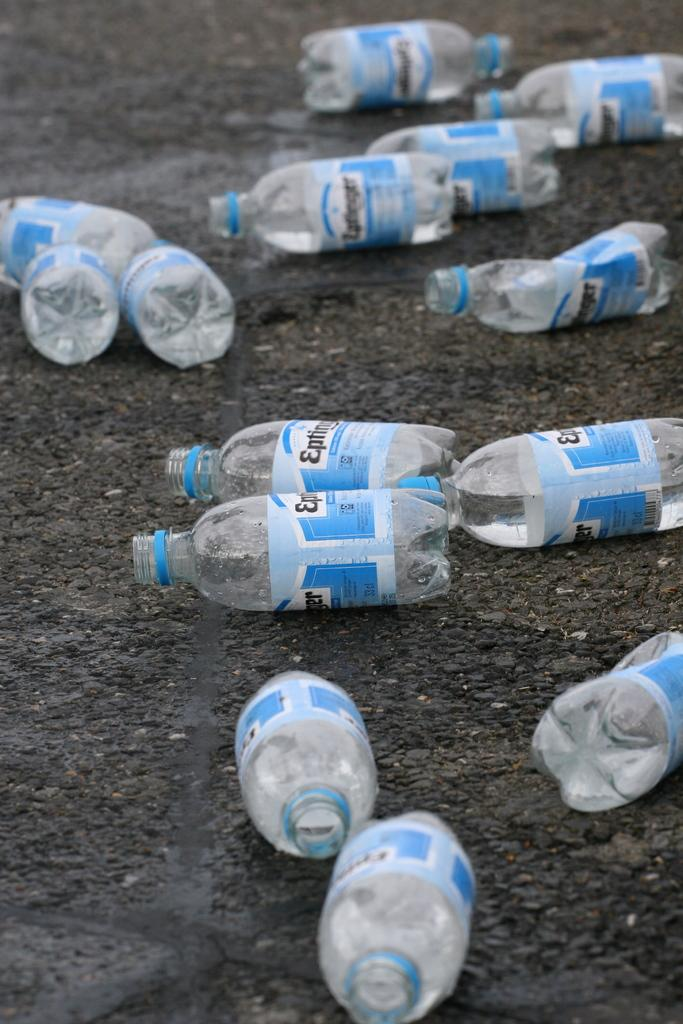<image>
Write a terse but informative summary of the picture. Empty plasitc bottles of Epting little the wet ground. 